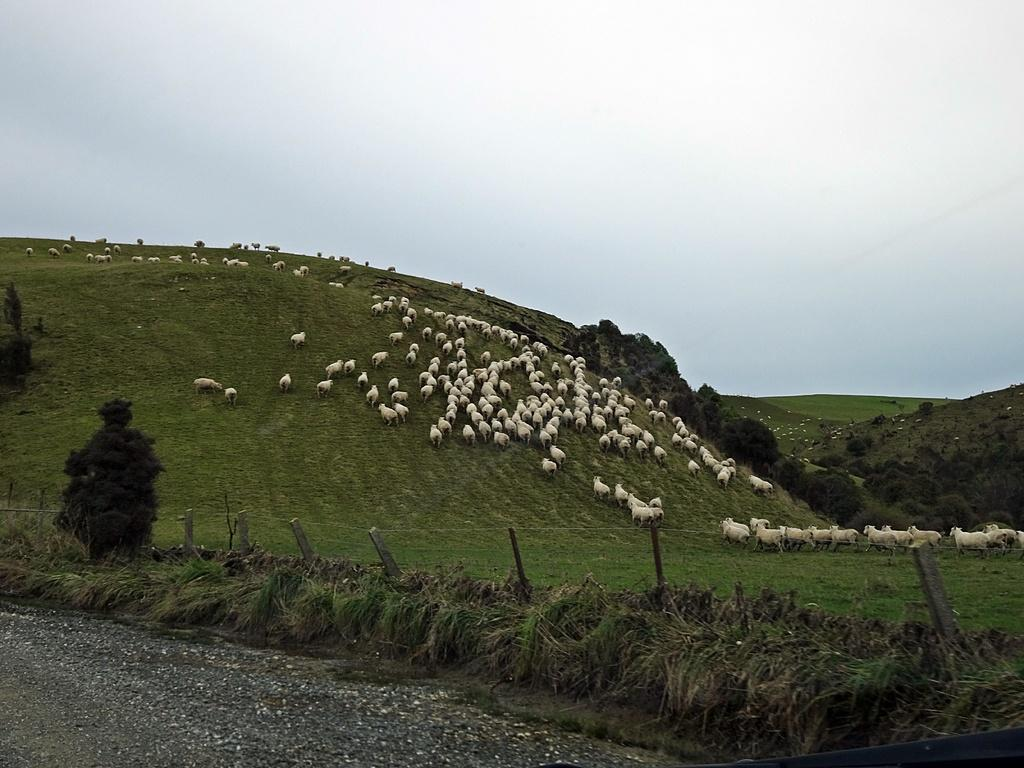What is the location of the animals in the image? The animals are on the grass in the image. What can be seen near the animals? There are trees to the side of the animals. What is the purpose of the fence in the image? The fence is present in the image, but its purpose is not explicitly stated. What is visible in the background of the image? The sky is visible in the background of the image. How does the wind affect the animals in the image? There is no mention of wind in the image, so its effect on the animals cannot be determined. 